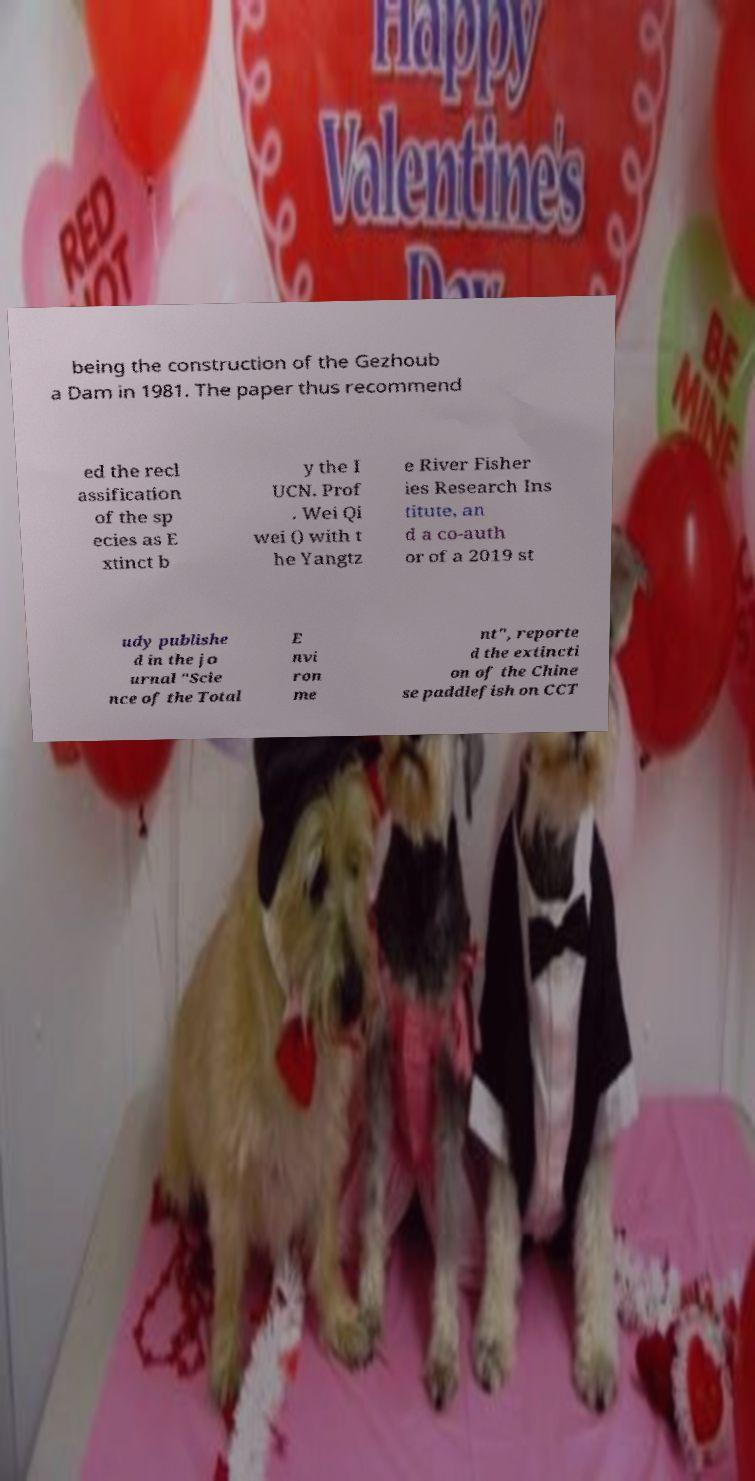Can you read and provide the text displayed in the image?This photo seems to have some interesting text. Can you extract and type it out for me? being the construction of the Gezhoub a Dam in 1981. The paper thus recommend ed the recl assification of the sp ecies as E xtinct b y the I UCN. Prof . Wei Qi wei () with t he Yangtz e River Fisher ies Research Ins titute, an d a co-auth or of a 2019 st udy publishe d in the jo urnal "Scie nce of the Total E nvi ron me nt", reporte d the extincti on of the Chine se paddlefish on CCT 